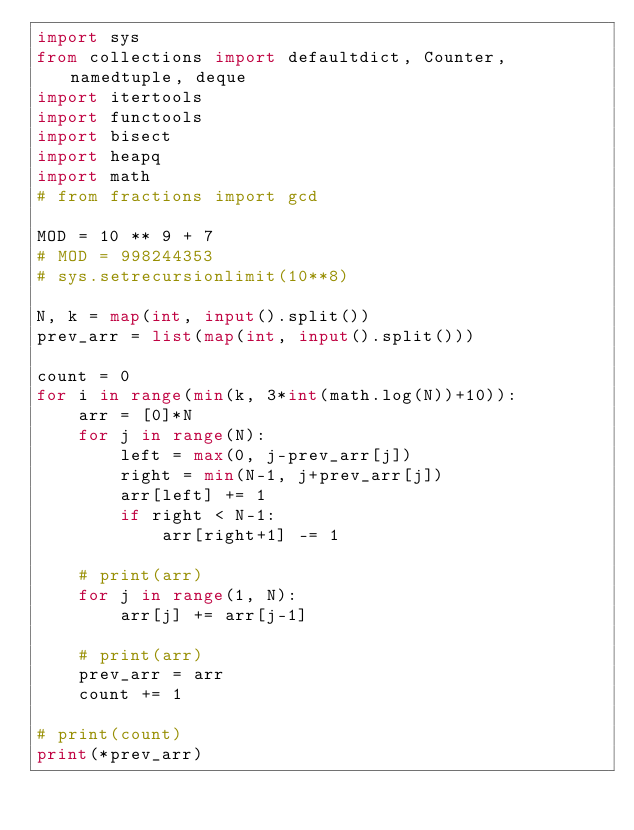Convert code to text. <code><loc_0><loc_0><loc_500><loc_500><_Python_>import sys
from collections import defaultdict, Counter, namedtuple, deque
import itertools
import functools
import bisect
import heapq
import math
# from fractions import gcd

MOD = 10 ** 9 + 7
# MOD = 998244353
# sys.setrecursionlimit(10**8)

N, k = map(int, input().split())
prev_arr = list(map(int, input().split()))

count = 0
for i in range(min(k, 3*int(math.log(N))+10)):
    arr = [0]*N
    for j in range(N):
        left = max(0, j-prev_arr[j])
        right = min(N-1, j+prev_arr[j])
        arr[left] += 1
        if right < N-1:
            arr[right+1] -= 1

    # print(arr)
    for j in range(1, N):
        arr[j] += arr[j-1]

    # print(arr)
    prev_arr = arr
    count += 1

# print(count)
print(*prev_arr)
</code> 